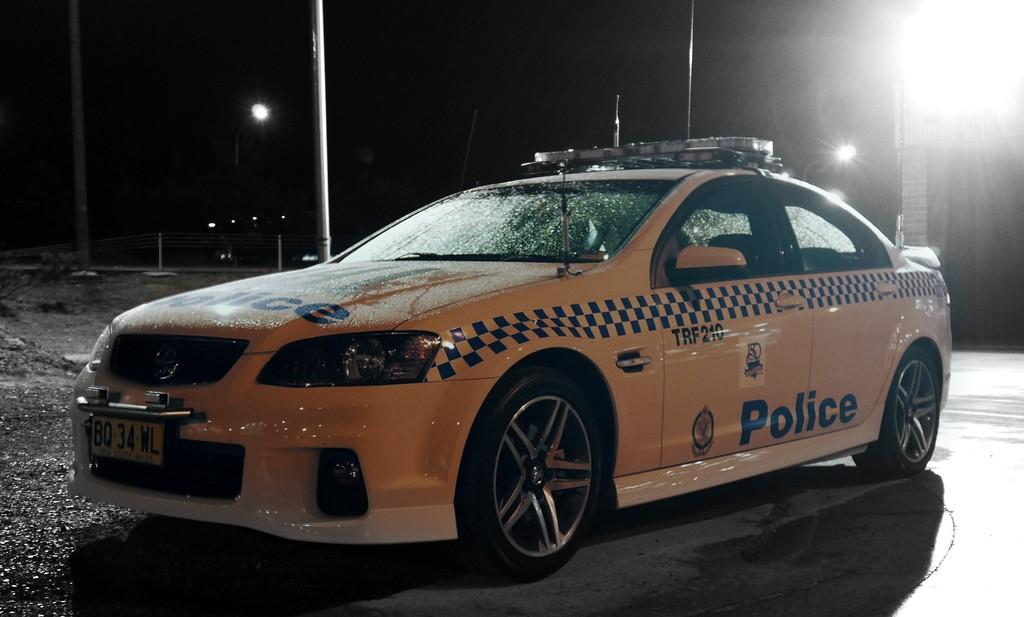What is the main subject of the image? There is a car on the road in the image. What else can be seen in the image besides the car? There are lights, poles, and a fence visible in the image. How would you describe the lighting conditions in the image? The background of the image is dark. What type of clouds can be seen in the image? There are no clouds visible in the image. How does the car rub against the poles in the image? The car does not rub against the poles in the image; it is simply driving on the road. 